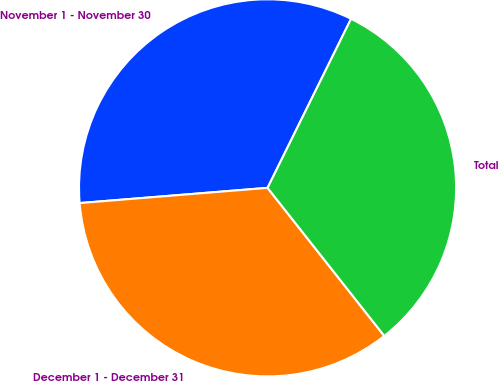<chart> <loc_0><loc_0><loc_500><loc_500><pie_chart><fcel>November 1 - November 30<fcel>December 1 - December 31<fcel>Total<nl><fcel>33.59%<fcel>34.34%<fcel>32.07%<nl></chart> 